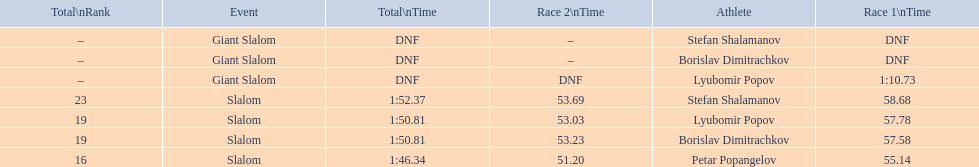I'm looking to parse the entire table for insights. Could you assist me with that? {'header': ['Total\\nRank', 'Event', 'Total\\nTime', 'Race 2\\nTime', 'Athlete', 'Race 1\\nTime'], 'rows': [['–', 'Giant Slalom', 'DNF', '–', 'Stefan Shalamanov', 'DNF'], ['–', 'Giant Slalom', 'DNF', '–', 'Borislav Dimitrachkov', 'DNF'], ['–', 'Giant Slalom', 'DNF', 'DNF', 'Lyubomir Popov', '1:10.73'], ['23', 'Slalom', '1:52.37', '53.69', 'Stefan Shalamanov', '58.68'], ['19', 'Slalom', '1:50.81', '53.03', 'Lyubomir Popov', '57.78'], ['19', 'Slalom', '1:50.81', '53.23', 'Borislav Dimitrachkov', '57.58'], ['16', 'Slalom', '1:46.34', '51.20', 'Petar Popangelov', '55.14']]} Who has the highest rank? Petar Popangelov. 